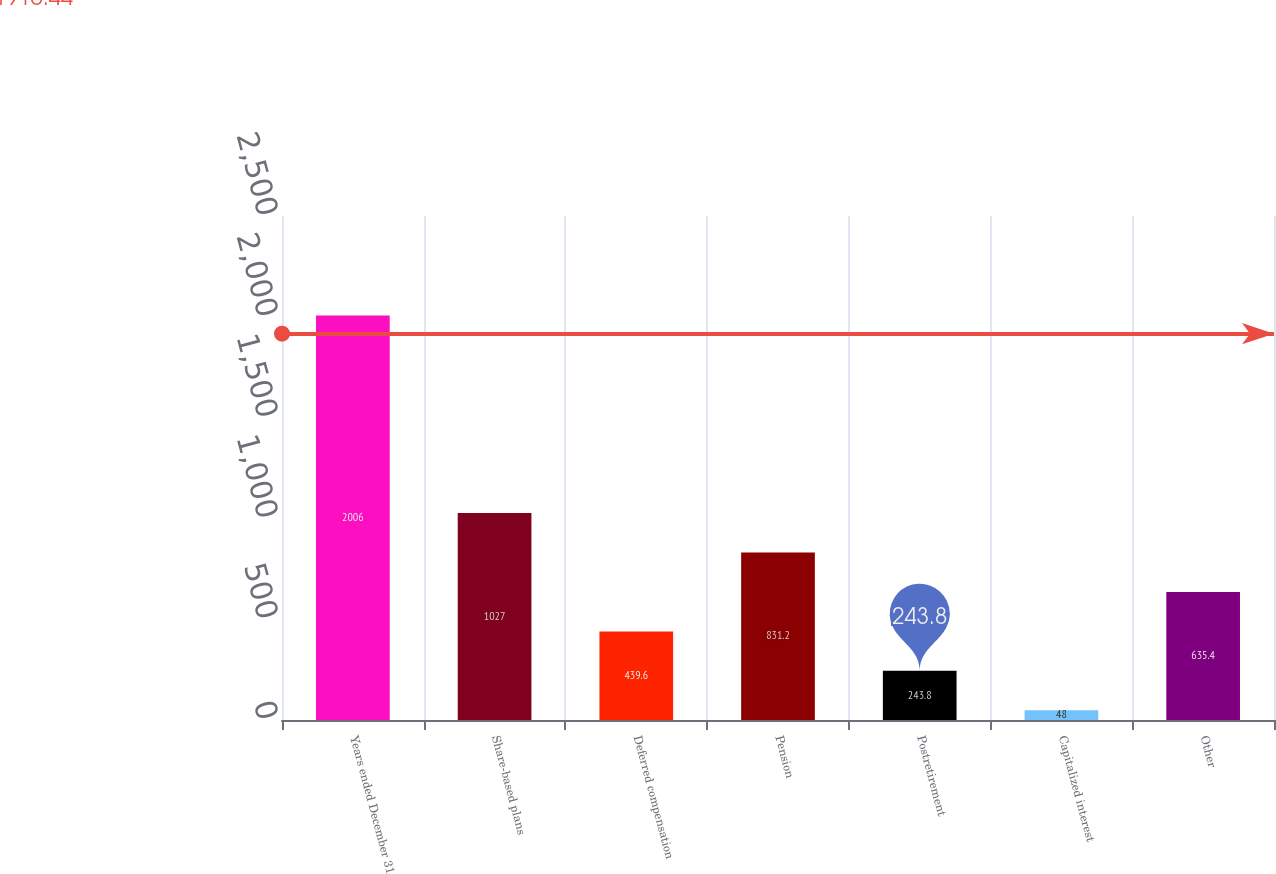<chart> <loc_0><loc_0><loc_500><loc_500><bar_chart><fcel>Years ended December 31<fcel>Share-based plans<fcel>Deferred compensation<fcel>Pension<fcel>Postretirement<fcel>Capitalized interest<fcel>Other<nl><fcel>2006<fcel>1027<fcel>439.6<fcel>831.2<fcel>243.8<fcel>48<fcel>635.4<nl></chart> 